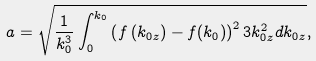<formula> <loc_0><loc_0><loc_500><loc_500>a = \sqrt { \frac { 1 } { k _ { 0 } ^ { 3 } } \int _ { 0 } ^ { k _ { 0 } } { \left ( { f \left ( { k _ { 0 z } } \right ) - f ( k _ { 0 } ) } \right ) ^ { 2 } 3 k _ { 0 z } ^ { 2 } d } k _ { 0 z } } ,</formula> 